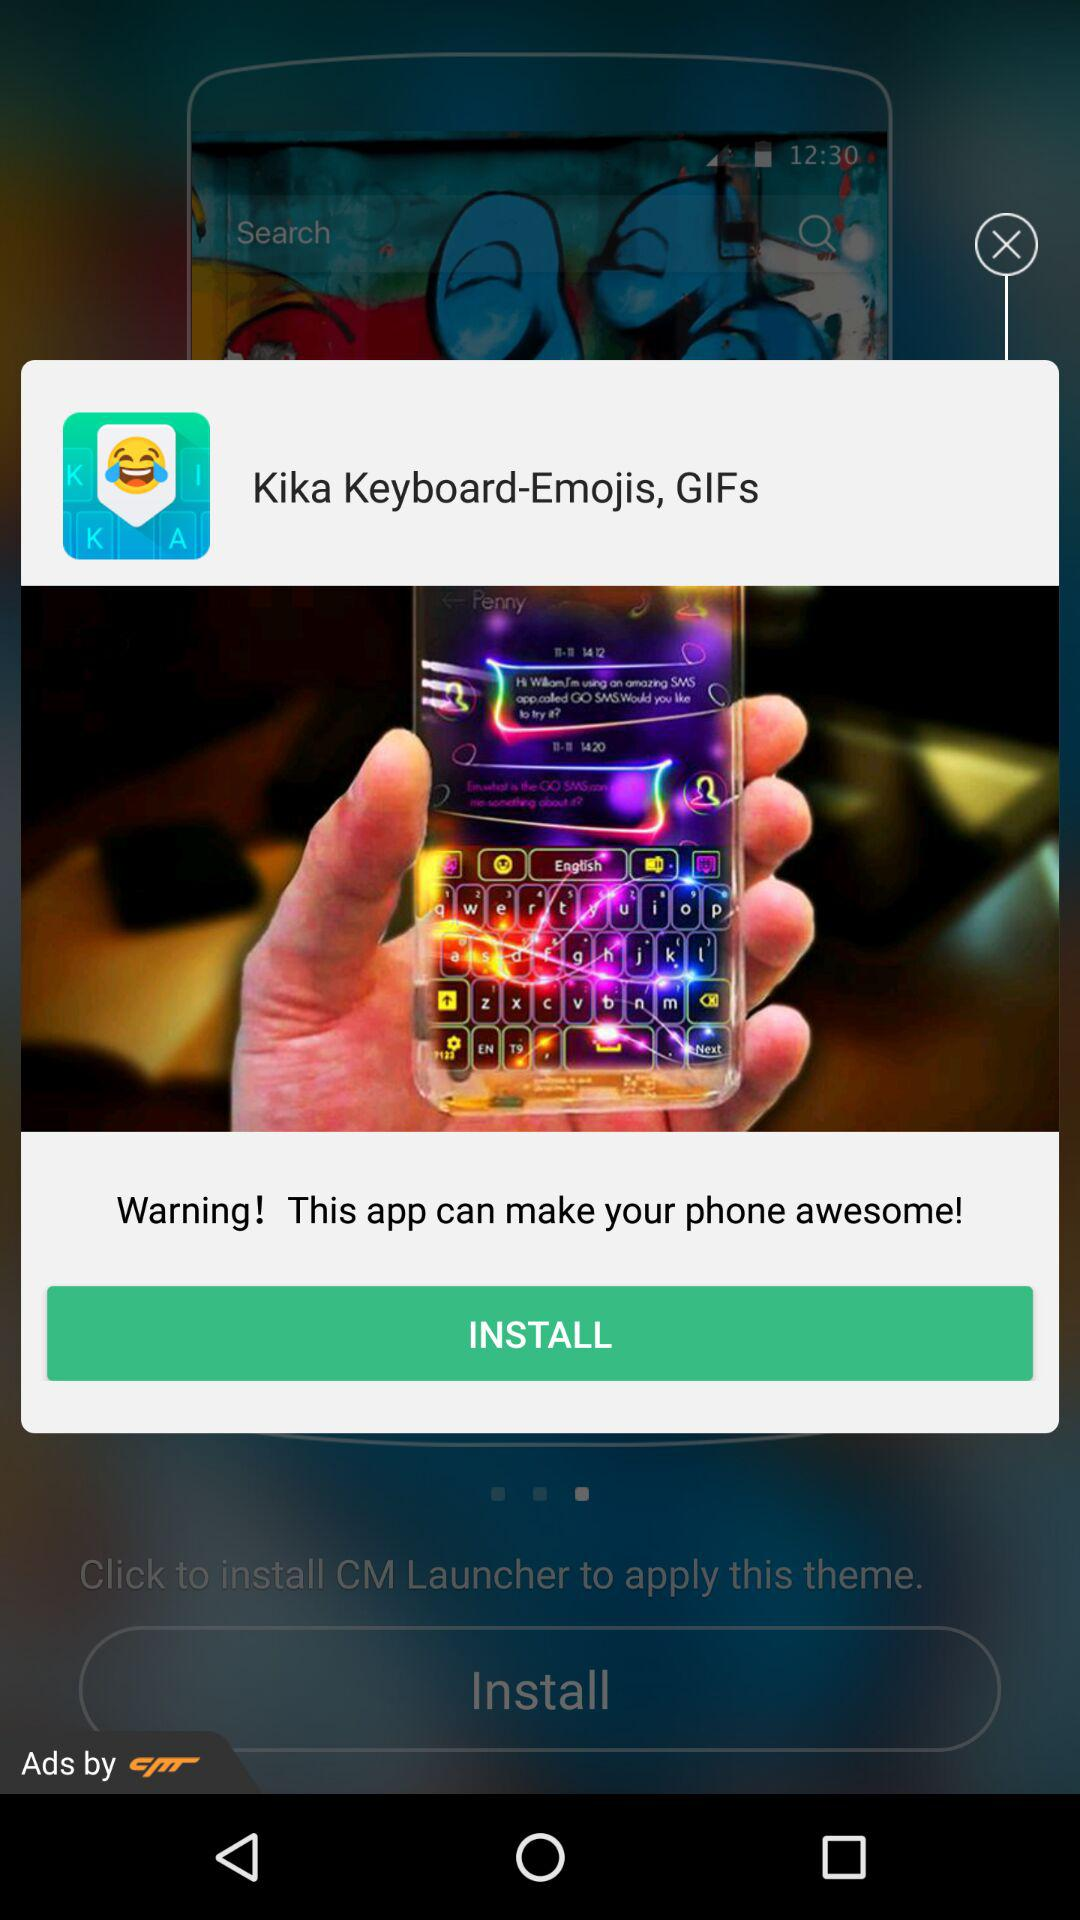How many pager indicators are on the screen?
Answer the question using a single word or phrase. 1 